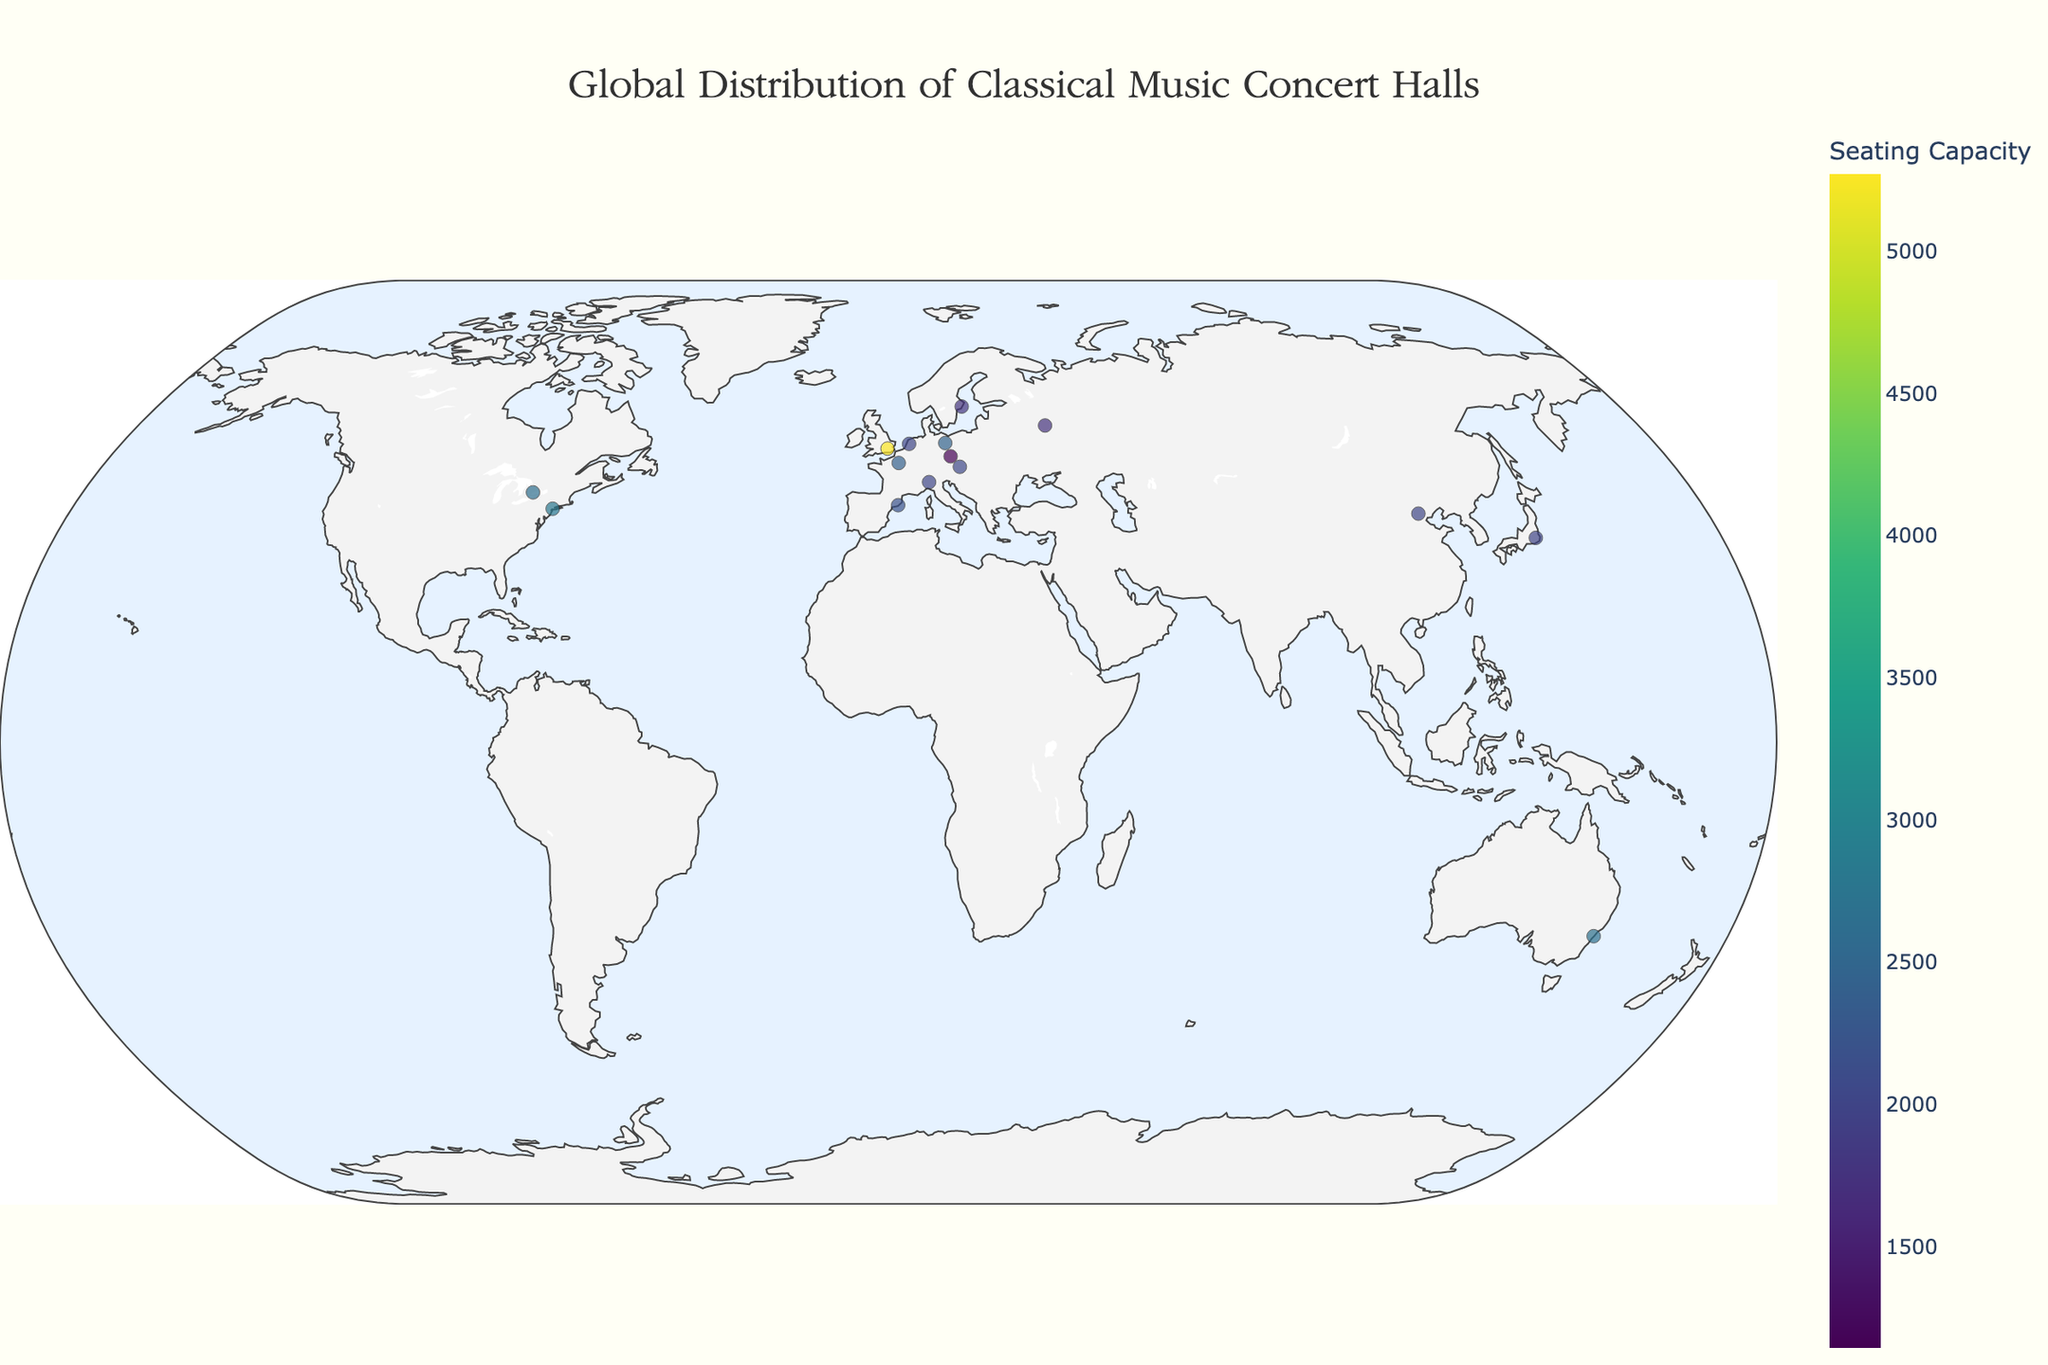What is the title of the figure? The title of the figure is located at the top center of the plot. It is styled with a large, elegant font. By looking at the figure, one can clearly see the title.
Answer: Global Distribution of Classical Music Concert Halls How many concert halls are shown in the figure? The plot shows different markers for each concert hall which can be counted by examining the locations of the markers on the map.
Answer: 15 Which concert hall has the largest seating capacity? The figure displays the seating capacities through different sized and colored markers. The largest marker in size and with the highest color intensity represents the concert hall with the largest capacity.
Answer: Royal Albert Hall Which two cities have the highest number of classical music concert halls in the figure? By observing the distribution of markers, one can identify cities that appear more than once. By counting the number of markers, it can be found which cities have the highest frequency.
Answer: Vienna and Berlin Between Europe and North America, which continent hosts more classical music concert halls according to the figure? By counting the number of concert halls located in each continent using the figure, it is possible to determine which continent hosts more halls.
Answer: Europe Compare the seating capacities of the concert halls in Vienna and Moscow. Which city has the larger capacity concert hall? By examining the markers for Vienna and Moscow and reading the seating capacity information displayed, one can compare the values.
Answer: Moscow What is the average seating capacity of the concert halls listed in the figure? To find the average seating capacity, sum the seating capacities of all concert halls and then divide by the number of concert halls.
Answer: (2044 + 2440 + 2804 + 5272 + 1737 + 2030 + 2400 + 2006 + 2037 + 2017 + 2679 + 2200 + 1144 + 1770 + 2630) / 15 = 2447 Which concert hall marker appears furthest to the east on the figure? By identifying and comparing the longitudes of markers displayed on the figure, the easternmost marker can be identified.
Answer: Suntory Hall, Tokyo How does the seating capacity of the Sydney Opera House Concert Hall compare to that of the Carnegie Hall in New York? By examining the figure and the information provided for each concert hall, compare their seating capacities.
Answer: Sydney Opera House Concert Hall has a smaller capacity (2679 vs. 2804) 